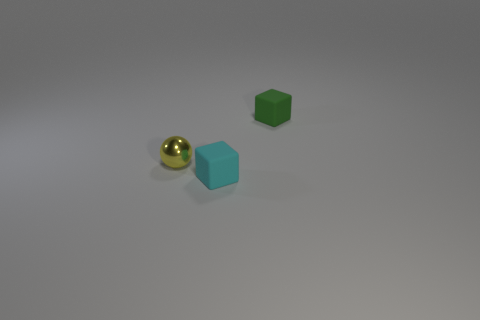Is there anything else that is made of the same material as the yellow object?
Provide a succinct answer. No. Is there a small metal thing right of the small block in front of the yellow ball?
Give a very brief answer. No. How many cyan balls have the same material as the small cyan thing?
Offer a very short reply. 0. How many tiny yellow metal things are in front of the yellow metallic ball?
Keep it short and to the point. 0. Is the number of large red spheres greater than the number of cyan cubes?
Provide a short and direct response. No. There is a small cube that is in front of the tiny cube behind the tiny cube to the left of the green rubber block; what is it made of?
Provide a short and direct response. Rubber. Is the color of the tiny rubber thing behind the tiny cyan object the same as the thing that is to the left of the cyan block?
Offer a terse response. No. There is a object on the right side of the small cube in front of the tiny cube behind the tiny metallic ball; what is its shape?
Ensure brevity in your answer.  Cube. What is the shape of the small object that is to the right of the yellow ball and behind the small cyan cube?
Keep it short and to the point. Cube. How many small cyan rubber objects are behind the matte object that is in front of the object that is to the right of the tiny cyan thing?
Your response must be concise. 0. 